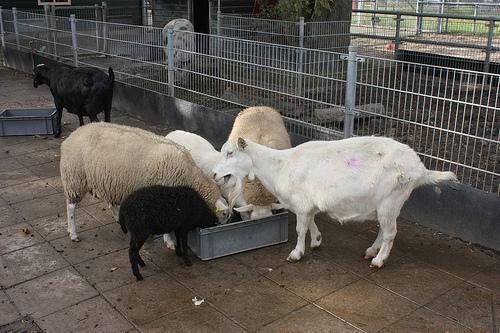How many goats are there?
Give a very brief answer. 5. How many goats are in the photo?
Give a very brief answer. 5. How many different kinds of animals are in the photo?
Give a very brief answer. 2. How many small goats are in the photo?
Give a very brief answer. 1. How many goats are black?
Give a very brief answer. 2. How many different colors are the goats?
Give a very brief answer. 3. How many goats are not eating?
Give a very brief answer. 2. 